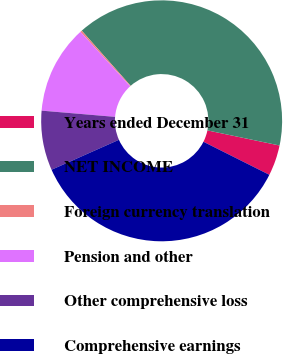Convert chart to OTSL. <chart><loc_0><loc_0><loc_500><loc_500><pie_chart><fcel>Years ended December 31<fcel>NET INCOME<fcel>Foreign currency translation<fcel>Pension and other<fcel>Other comprehensive loss<fcel>Comprehensive earnings<nl><fcel>4.11%<fcel>39.83%<fcel>0.23%<fcel>11.88%<fcel>8.0%<fcel>35.95%<nl></chart> 